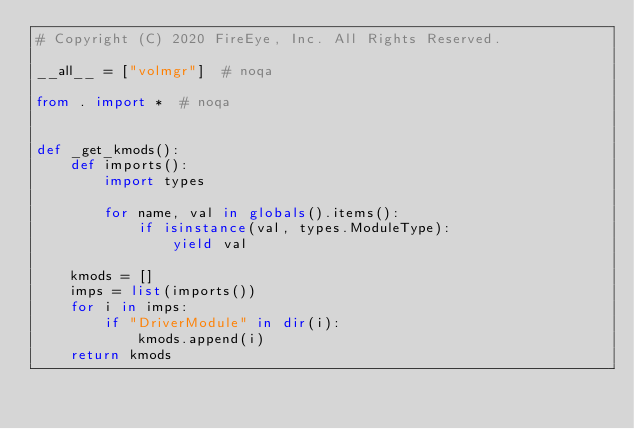<code> <loc_0><loc_0><loc_500><loc_500><_Python_># Copyright (C) 2020 FireEye, Inc. All Rights Reserved.

__all__ = ["volmgr"]  # noqa

from . import *  # noqa


def _get_kmods():
    def imports():
        import types

        for name, val in globals().items():
            if isinstance(val, types.ModuleType):
                yield val

    kmods = []
    imps = list(imports())
    for i in imps:
        if "DriverModule" in dir(i):
            kmods.append(i)
    return kmods
</code> 